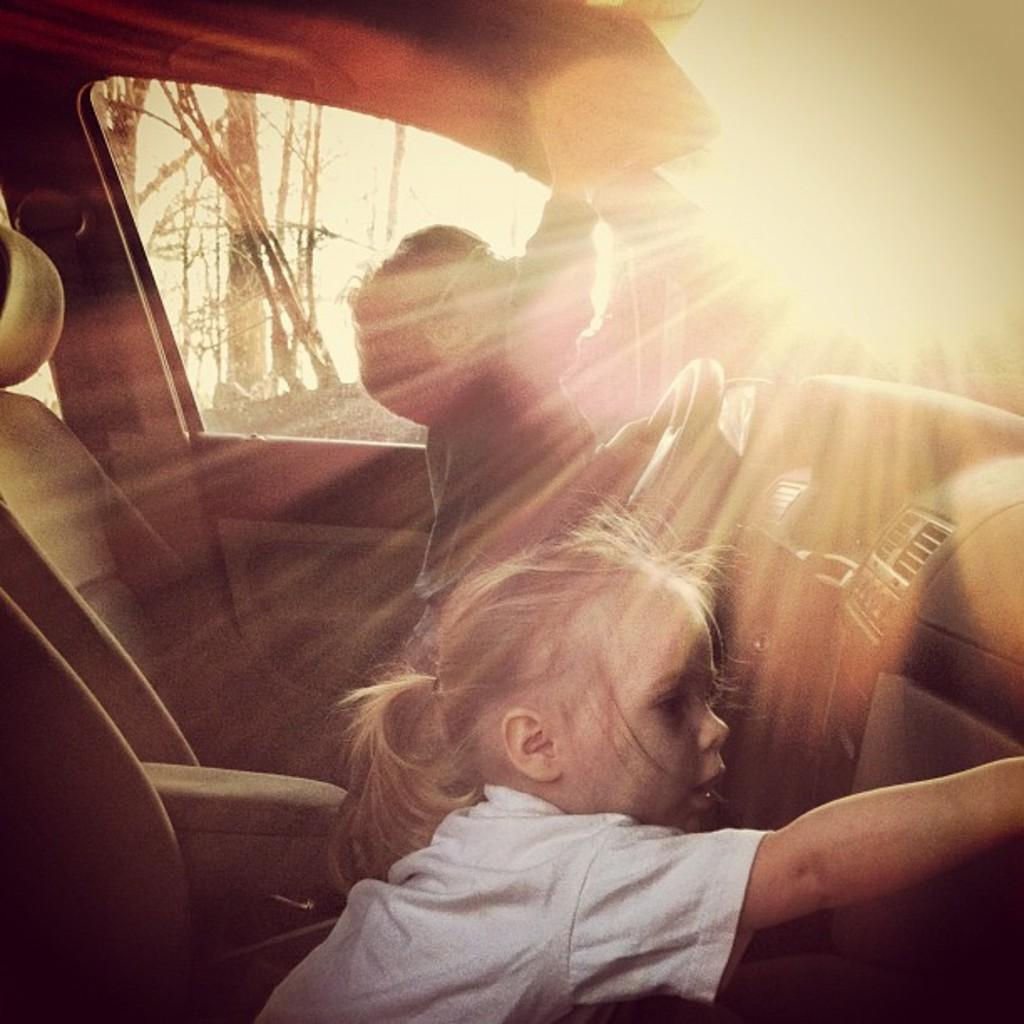What type of location is depicted in the image? The image is an inside view of a car. How many people are visible in the car? There is a girl and a boy sitting on seats in the car. What can be seen in the background of the image? There are trees visible in the background. What is the source of light on the right side of the image? There is sunlight on the right side of the image. What type of drum is the girl playing in the image? There is no drum present in the image; it is an inside view of a car with a girl and a boy sitting on seats. 